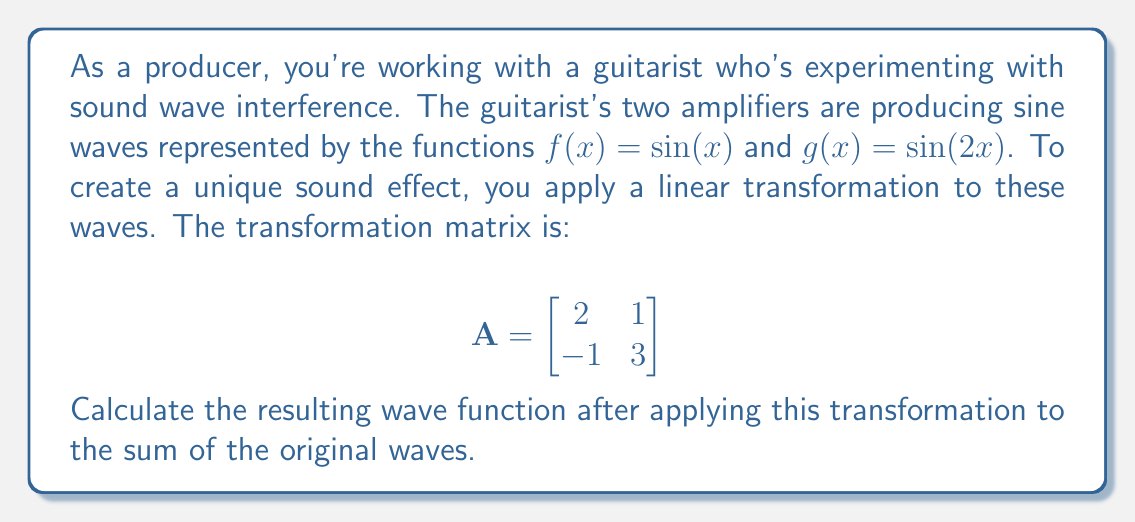Solve this math problem. 1. First, we need to represent the sum of the original waves as a vector function:
   $$\vec{v}(x) = \begin{bmatrix}
   f(x) \\
   g(x)
   \end{bmatrix} = \begin{bmatrix}
   \sin(x) \\
   \sin(2x)
   \end{bmatrix}$$

2. To apply the linear transformation, we multiply the matrix A by the vector function:
   $$A\vec{v}(x) = \begin{bmatrix}
   2 & 1 \\
   -1 & 3
   \end{bmatrix} \begin{bmatrix}
   \sin(x) \\
   \sin(2x)
   \end{bmatrix}$$

3. Perform the matrix multiplication:
   $$A\vec{v}(x) = \begin{bmatrix}
   2\sin(x) + \sin(2x) \\
   -\sin(x) + 3\sin(2x)
   \end{bmatrix}$$

4. The resulting wave function is the sum of the two components:
   $h(x) = [2\sin(x) + \sin(2x)] + [-\sin(x) + 3\sin(2x)]$

5. Simplify:
   $h(x) = 2\sin(x) + \sin(2x) - \sin(x) + 3\sin(2x)$
   $h(x) = \sin(x) + 4\sin(2x)$

This is the final wave function after applying the linear transformation.
Answer: $h(x) = \sin(x) + 4\sin(2x)$ 